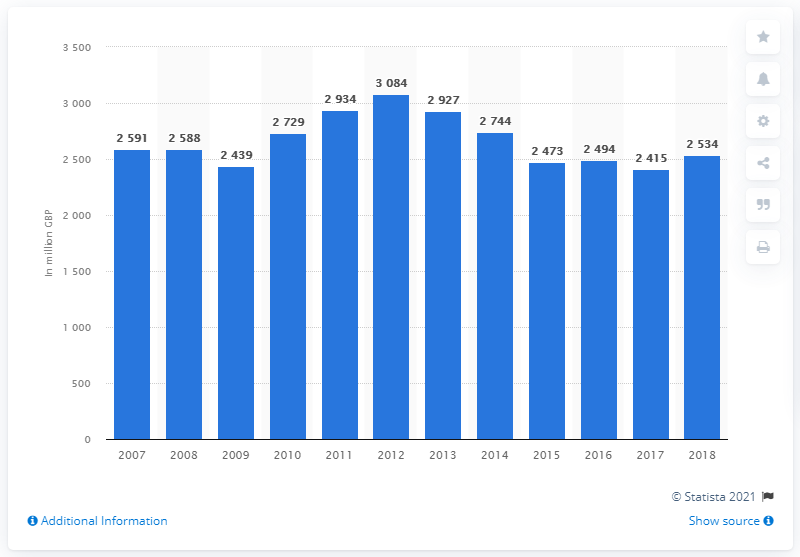Mention a couple of crucial points in this snapshot. Commercial property insurance outgoings decreased almost year-on-year in 2012. The expenses for commercial motor insurance in 2018 were approximately 2,494. 